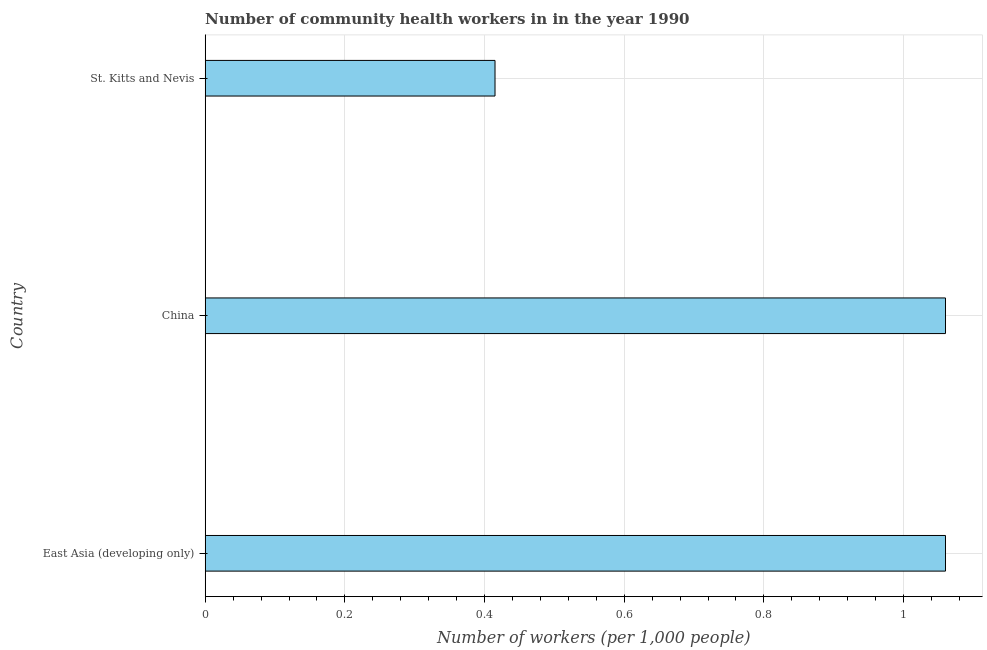Does the graph contain any zero values?
Provide a short and direct response. No. What is the title of the graph?
Provide a short and direct response. Number of community health workers in in the year 1990. What is the label or title of the X-axis?
Give a very brief answer. Number of workers (per 1,0 people). What is the label or title of the Y-axis?
Offer a very short reply. Country. What is the number of community health workers in St. Kitts and Nevis?
Offer a terse response. 0.41. Across all countries, what is the maximum number of community health workers?
Keep it short and to the point. 1.06. Across all countries, what is the minimum number of community health workers?
Ensure brevity in your answer.  0.41. In which country was the number of community health workers maximum?
Make the answer very short. East Asia (developing only). In which country was the number of community health workers minimum?
Your answer should be very brief. St. Kitts and Nevis. What is the sum of the number of community health workers?
Ensure brevity in your answer.  2.54. What is the difference between the number of community health workers in China and St. Kitts and Nevis?
Provide a short and direct response. 0.65. What is the average number of community health workers per country?
Ensure brevity in your answer.  0.84. What is the median number of community health workers?
Provide a succinct answer. 1.06. What is the ratio of the number of community health workers in China to that in East Asia (developing only)?
Make the answer very short. 1. What is the difference between the highest and the second highest number of community health workers?
Your answer should be very brief. 0. Is the sum of the number of community health workers in China and St. Kitts and Nevis greater than the maximum number of community health workers across all countries?
Your response must be concise. Yes. What is the difference between the highest and the lowest number of community health workers?
Your answer should be very brief. 0.65. How many bars are there?
Keep it short and to the point. 3. Are all the bars in the graph horizontal?
Your response must be concise. Yes. How many countries are there in the graph?
Make the answer very short. 3. Are the values on the major ticks of X-axis written in scientific E-notation?
Your answer should be compact. No. What is the Number of workers (per 1,000 people) in East Asia (developing only)?
Offer a very short reply. 1.06. What is the Number of workers (per 1,000 people) in China?
Your answer should be compact. 1.06. What is the Number of workers (per 1,000 people) in St. Kitts and Nevis?
Offer a very short reply. 0.41. What is the difference between the Number of workers (per 1,000 people) in East Asia (developing only) and China?
Your answer should be compact. 0. What is the difference between the Number of workers (per 1,000 people) in East Asia (developing only) and St. Kitts and Nevis?
Your response must be concise. 0.65. What is the difference between the Number of workers (per 1,000 people) in China and St. Kitts and Nevis?
Offer a very short reply. 0.65. What is the ratio of the Number of workers (per 1,000 people) in East Asia (developing only) to that in St. Kitts and Nevis?
Keep it short and to the point. 2.55. What is the ratio of the Number of workers (per 1,000 people) in China to that in St. Kitts and Nevis?
Your response must be concise. 2.55. 